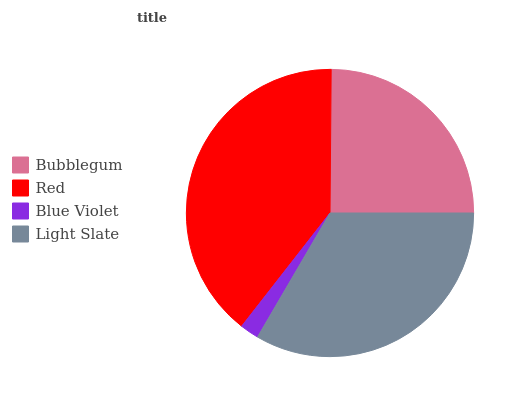Is Blue Violet the minimum?
Answer yes or no. Yes. Is Red the maximum?
Answer yes or no. Yes. Is Red the minimum?
Answer yes or no. No. Is Blue Violet the maximum?
Answer yes or no. No. Is Red greater than Blue Violet?
Answer yes or no. Yes. Is Blue Violet less than Red?
Answer yes or no. Yes. Is Blue Violet greater than Red?
Answer yes or no. No. Is Red less than Blue Violet?
Answer yes or no. No. Is Light Slate the high median?
Answer yes or no. Yes. Is Bubblegum the low median?
Answer yes or no. Yes. Is Red the high median?
Answer yes or no. No. Is Light Slate the low median?
Answer yes or no. No. 